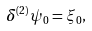Convert formula to latex. <formula><loc_0><loc_0><loc_500><loc_500>\delta ^ { ( 2 ) } \psi _ { 0 } = \xi _ { 0 } ,</formula> 